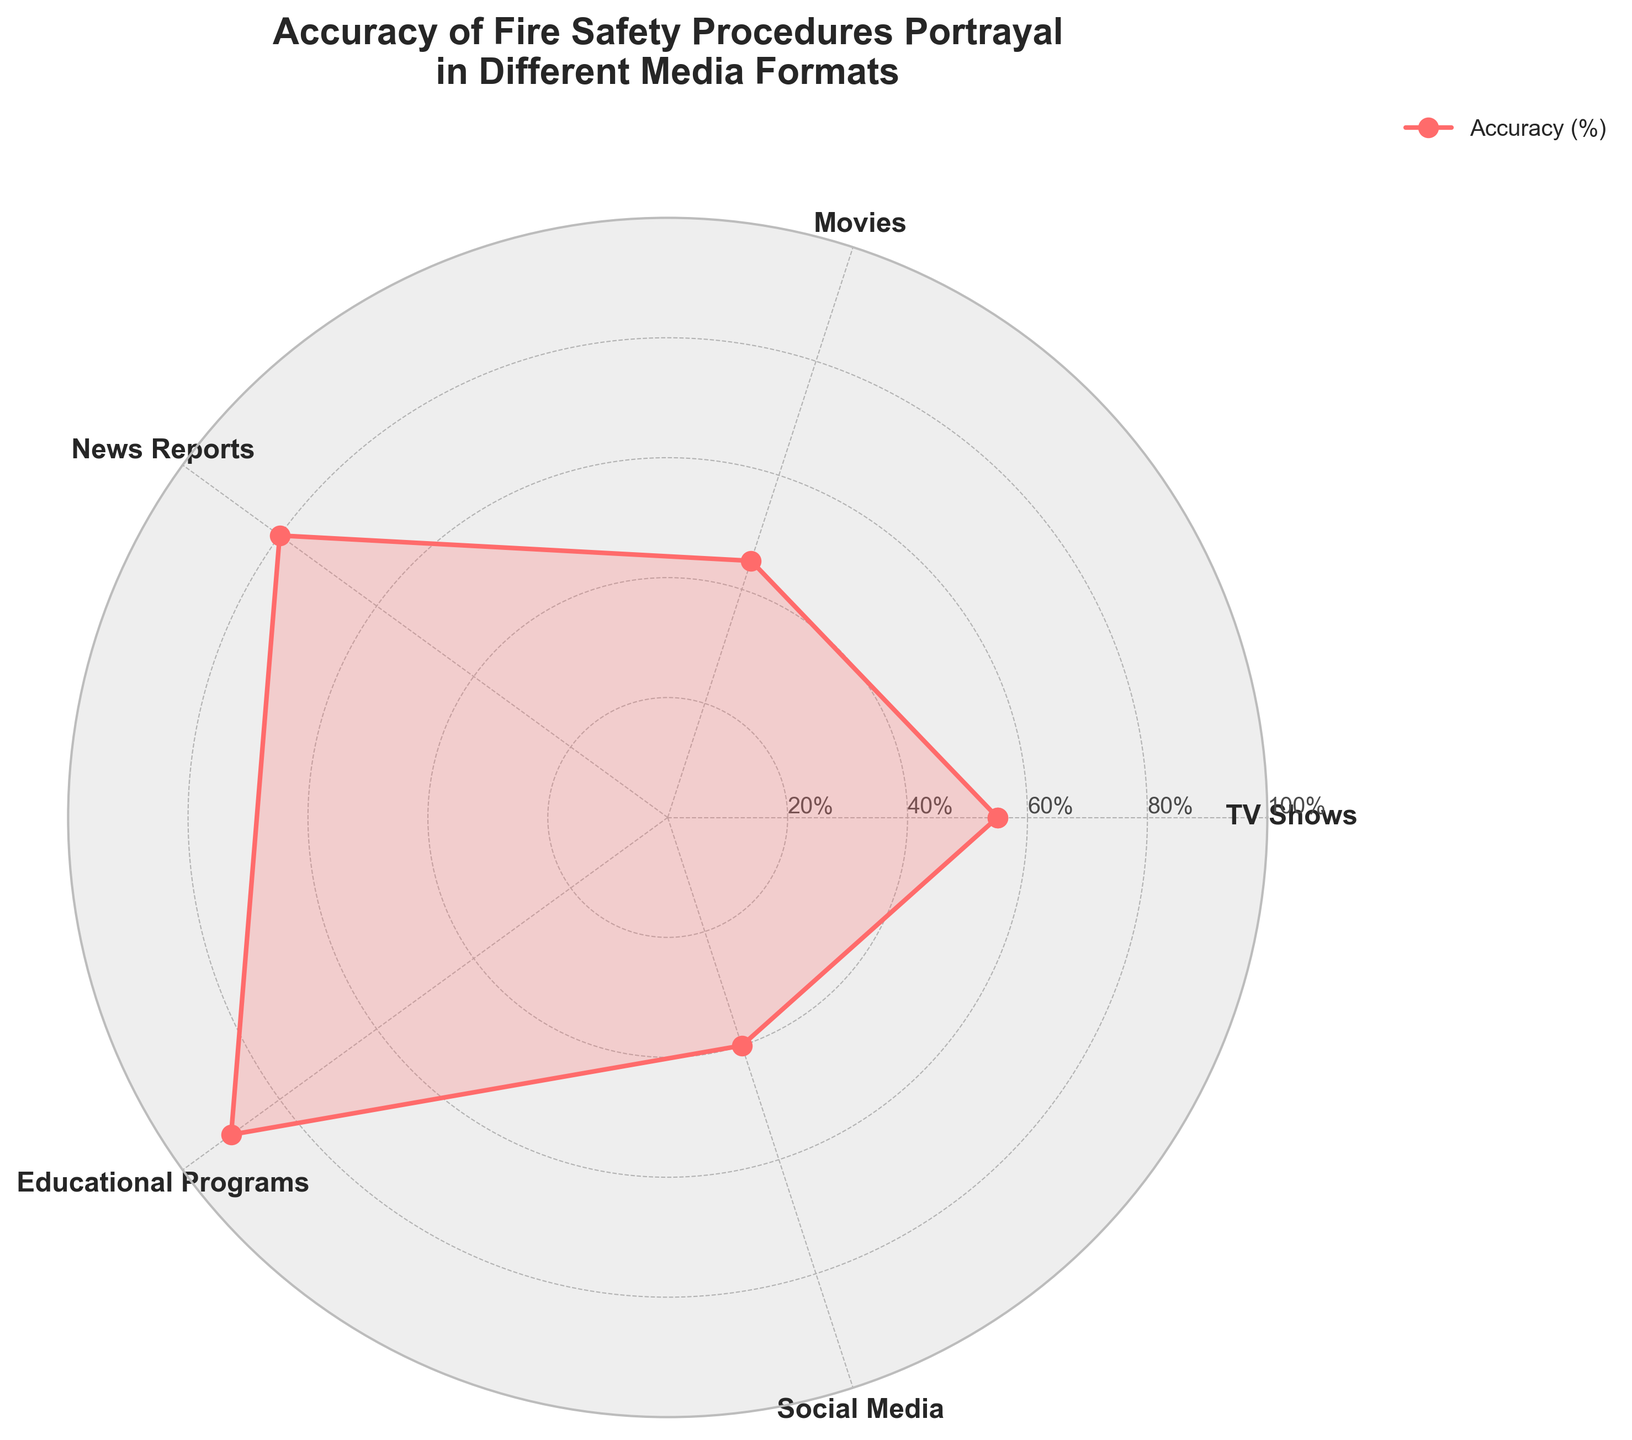What is the title of the radar chart? The title is located at the top of the radar chart. By looking at the title, we can identify it.
Answer: Accuracy of Fire Safety Procedures Portrayal in Different Media Formats Which media format has the highest accuracy in portraying fire safety procedures? To find the highest accuracy, we look at the value closest to the outer edge of the radar chart, which is at 90%. The label indicates this corresponds to Educational Programs.
Answer: Educational Programs Which media format has the lowest accuracy in portraying fire safety procedures? To determine the lowest accuracy, we look for the value closest to the center of the radar chart, which is at 40%. The label indicates this corresponds to Social Media.
Answer: Social Media What is the accuracy difference between TV shows and movies? We find the values for both media formats, which are 55% for TV shows and 45% for movies. Then we calculate the difference: 55% - 45% = 10%.
Answer: 10% What is the average accuracy of all the media formats shown? First, sum all the accuracy percentages: 55% + 45% + 80% + 90% + 40% = 310%. Then, divide by the number of formats, which is 5: 310% / 5 = 62%.
Answer: 62% Which media format has an accuracy closest to 50%? We look for the media format with an accuracy value nearest to 50%. TV shows have an accuracy of 55%, which is the closest.
Answer: TV Shows How much more accurate are educational programs compared to social media? Identify the accuracy values: educational programs at 90% and social media at 40%. Calculate the difference: 90% - 40% = 50%.
Answer: 50% Rank the media formats in order of their accuracy in portraying fire safety procedures from highest to lowest. List the accuracy values in descending order and match them to their corresponding media formats: 90% (Educational Programs), 80% (News Reports), 55% (TV Shows), 45% (Movies), 40% (Social Media).
Answer: Educational Programs, News Reports, TV Shows, Movies, Social Media On the radar chart, what is the range of the y-axis labels? The range of y-axis labels can be seen on the circular ring lines, starting from 20% and going up to 100% in increments of 20%.
Answer: 20% to 100% What percentage of accuracy do news reports have in portraying fire safety procedures? By referring to the radar chart, we find that news reports have an accuracy value labeled as 80%.
Answer: 80% 